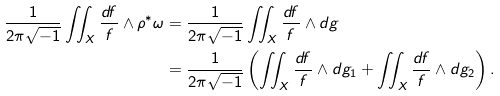Convert formula to latex. <formula><loc_0><loc_0><loc_500><loc_500>\frac { 1 } { 2 \pi \sqrt { - 1 } } \iint _ { X } \frac { d f } { f } \wedge \rho ^ { * } \omega & = \frac { 1 } { 2 \pi \sqrt { - 1 } } \iint _ { X } \frac { d f } { f } \wedge d g \\ & = \frac { 1 } { 2 \pi \sqrt { - 1 } } \left ( \iint _ { X } \frac { d f } { f } \wedge d g _ { 1 } + \iint _ { X } \frac { d f } { f } \wedge d g _ { 2 } \right ) .</formula> 